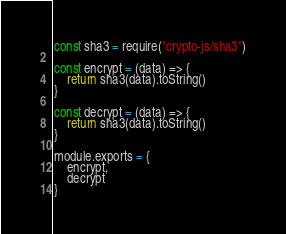<code> <loc_0><loc_0><loc_500><loc_500><_JavaScript_>const sha3 = require("crypto-js/sha3")

const encrypt = (data) => {
    return sha3(data).toString()
}

const decrypt = (data) => {
    return sha3(data).toString()
}

module.exports = {
    encrypt,
    decrypt
}</code> 